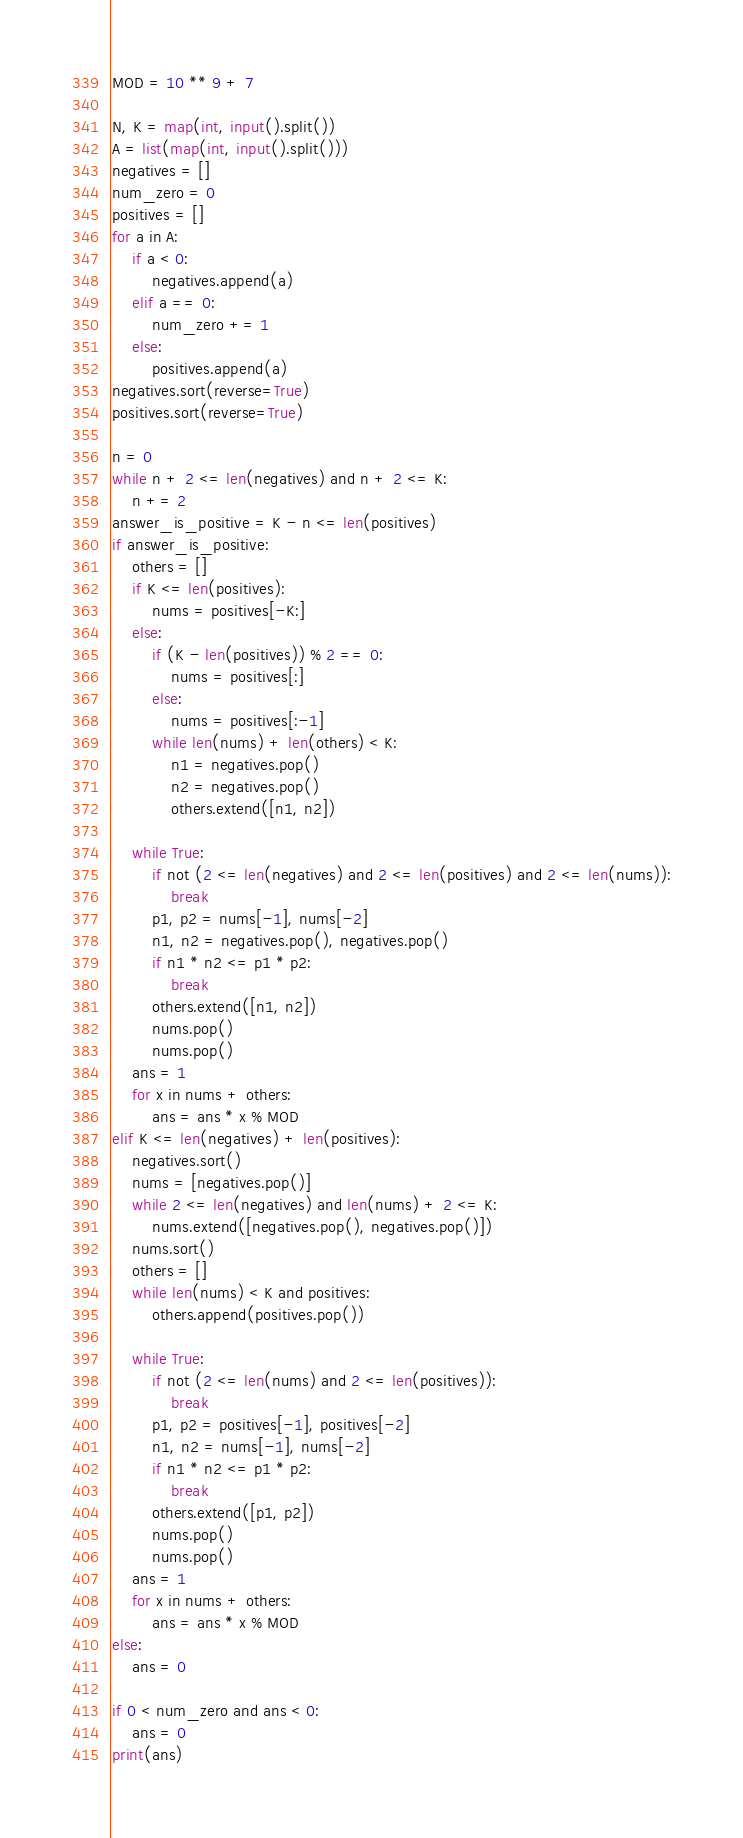Convert code to text. <code><loc_0><loc_0><loc_500><loc_500><_Python_>MOD = 10 ** 9 + 7

N, K = map(int, input().split())
A = list(map(int, input().split()))
negatives = []
num_zero = 0
positives = []
for a in A:
    if a < 0:
        negatives.append(a)
    elif a == 0:
        num_zero += 1
    else:
        positives.append(a)
negatives.sort(reverse=True)
positives.sort(reverse=True)

n = 0
while n + 2 <= len(negatives) and n + 2 <= K:
    n += 2
answer_is_positive = K - n <= len(positives)
if answer_is_positive:
    others = []
    if K <= len(positives):
        nums = positives[-K:]
    else:
        if (K - len(positives)) % 2 == 0:
            nums = positives[:]
        else:
            nums = positives[:-1]
        while len(nums) + len(others) < K:
            n1 = negatives.pop()
            n2 = negatives.pop()
            others.extend([n1, n2])

    while True:
        if not (2 <= len(negatives) and 2 <= len(positives) and 2 <= len(nums)):
            break
        p1, p2 = nums[-1], nums[-2]
        n1, n2 = negatives.pop(), negatives.pop()
        if n1 * n2 <= p1 * p2:
            break
        others.extend([n1, n2])
        nums.pop()
        nums.pop()
    ans = 1
    for x in nums + others:
        ans = ans * x % MOD
elif K <= len(negatives) + len(positives):
    negatives.sort()
    nums = [negatives.pop()]
    while 2 <= len(negatives) and len(nums) + 2 <= K:
        nums.extend([negatives.pop(), negatives.pop()])
    nums.sort()
    others = []
    while len(nums) < K and positives:
        others.append(positives.pop())

    while True:
        if not (2 <= len(nums) and 2 <= len(positives)):
            break
        p1, p2 = positives[-1], positives[-2]
        n1, n2 = nums[-1], nums[-2]
        if n1 * n2 <= p1 * p2:
            break
        others.extend([p1, p2])
        nums.pop()
        nums.pop()
    ans = 1
    for x in nums + others:
        ans = ans * x % MOD
else:
    ans = 0

if 0 < num_zero and ans < 0:
    ans = 0
print(ans)</code> 